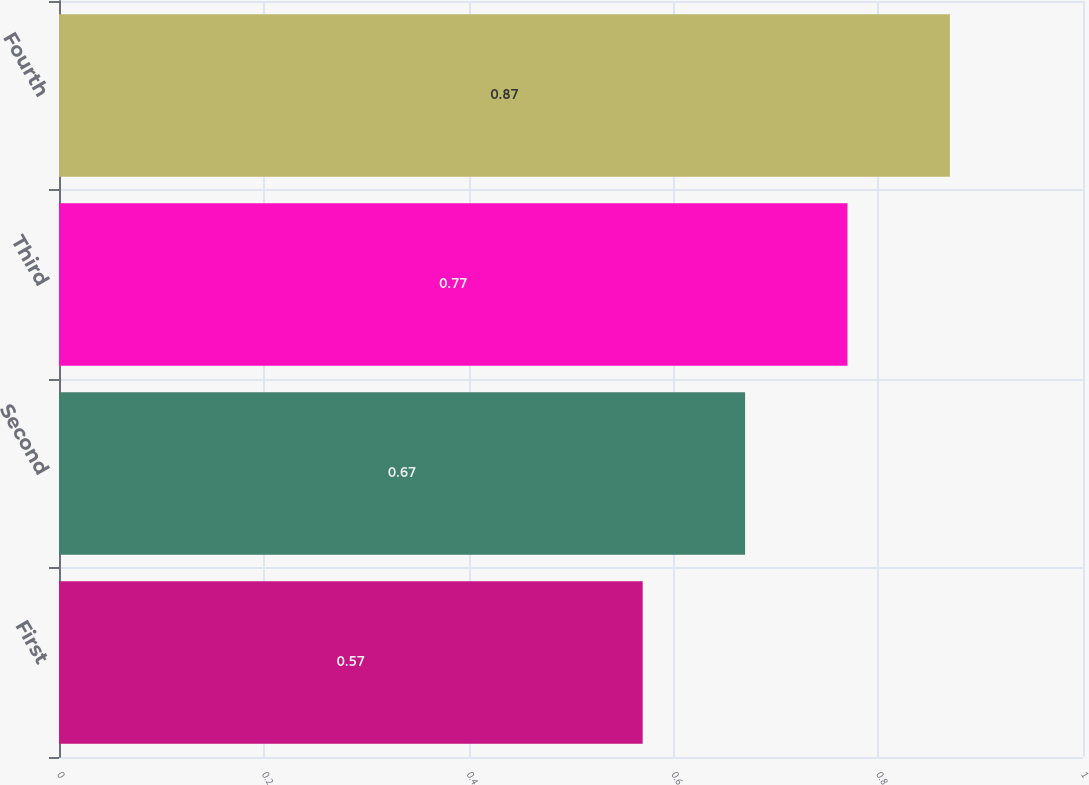Convert chart to OTSL. <chart><loc_0><loc_0><loc_500><loc_500><bar_chart><fcel>First<fcel>Second<fcel>Third<fcel>Fourth<nl><fcel>0.57<fcel>0.67<fcel>0.77<fcel>0.87<nl></chart> 